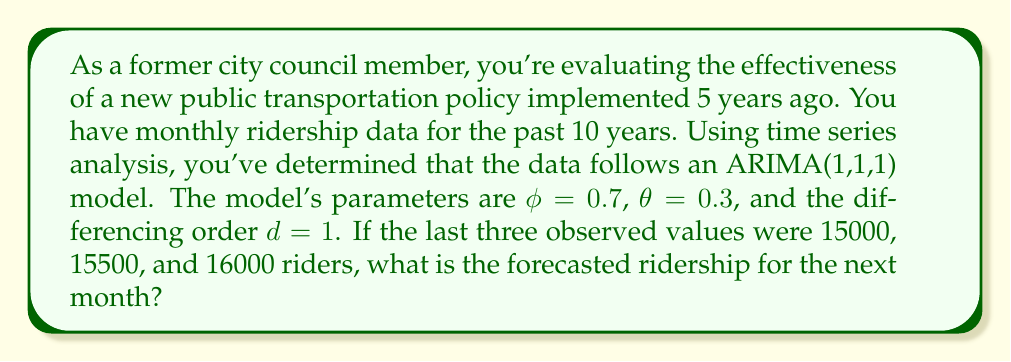Can you answer this question? To forecast the next value in an ARIMA(1,1,1) model, we need to follow these steps:

1) Recall the ARIMA(1,1,1) model equation:
   $$(1 - \phi B)(1 - B)y_t = (1 + \theta B)\epsilon_t$$

   Where $B$ is the backshift operator, $\phi$ is the AR parameter, $\theta$ is the MA parameter, and $\epsilon_t$ is white noise.

2) Expand this equation:
   $$y_t - (1 + \phi)y_{t-1} + \phi y_{t-2} = \epsilon_t + \theta\epsilon_{t-1}$$

3) Rearrange to isolate $y_t$:
   $$y_t = (1 + \phi)y_{t-1} - \phi y_{t-2} + \epsilon_t + \theta\epsilon_{t-1}$$

4) For forecasting, we set future error terms to their expected value of 0:
   $$\hat{y}_{t+1} = (1 + \phi)y_t - \phi y_{t-1} + \theta\epsilon_t$$

5) We need to calculate $\epsilon_t$. We can do this by using the model equation:
   $$\epsilon_t = y_t - (1 + \phi)y_{t-1} + \phi y_{t-2}$$

6) Using the given values:
   $$\epsilon_t = 16000 - (1 + 0.7) * 15500 + 0.7 * 15000 = -350$$

7) Now we can forecast the next value:
   $$\hat{y}_{t+1} = (1 + 0.7) * 16000 - 0.7 * 15500 + 0.3 * (-350)$$
   $$= 27200 - 10850 - 105 = 16245$$

Therefore, the forecasted ridership for the next month is 16,245 riders.
Answer: 16,245 riders 